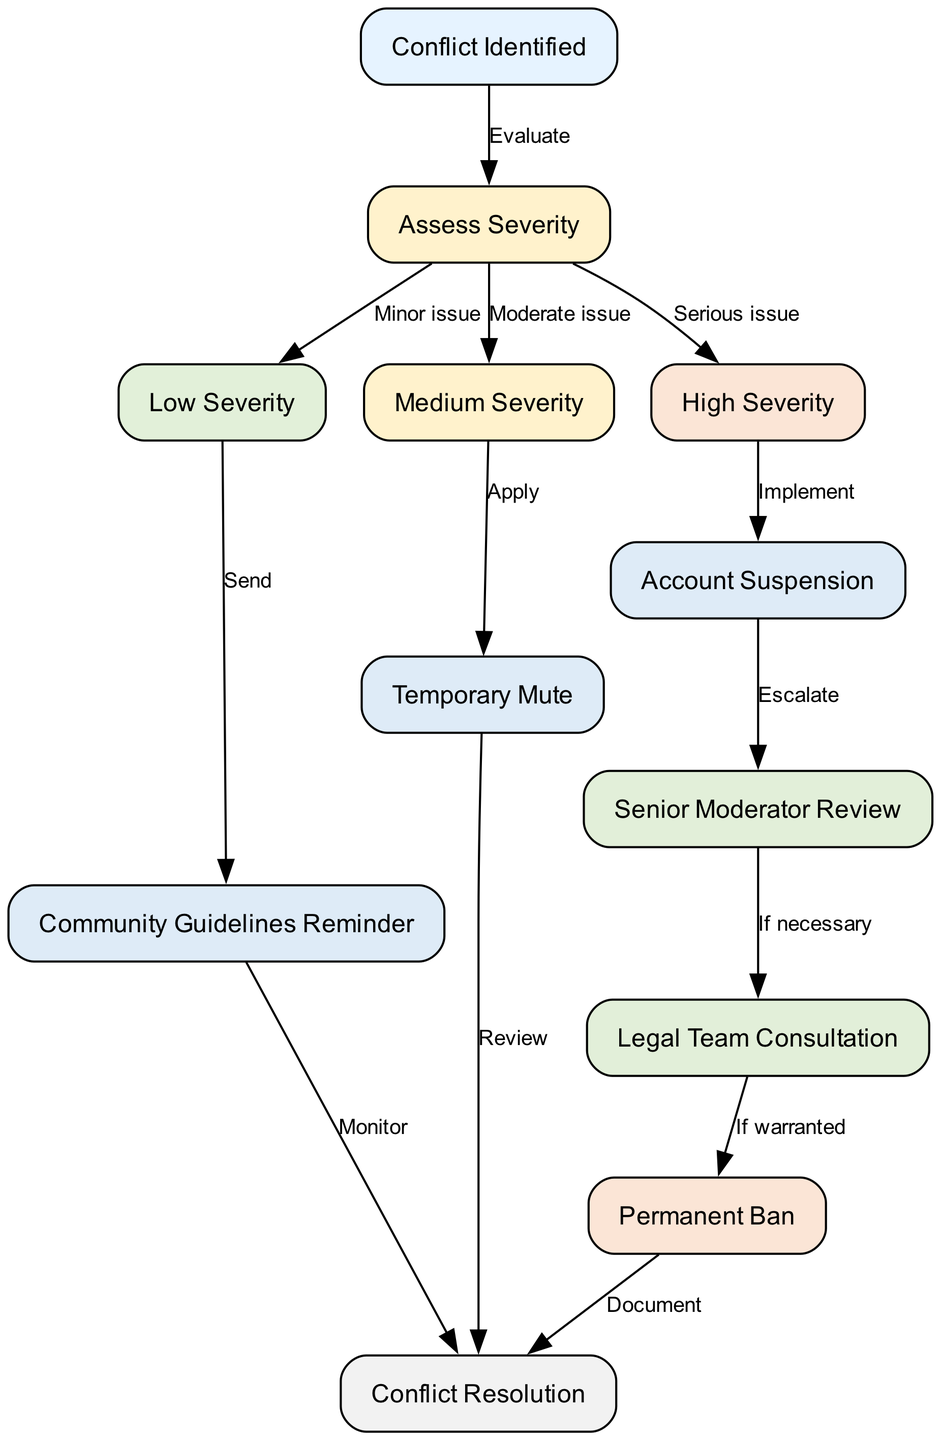What is the first node in the diagram? The first node in the diagram is labeled "Conflict Identified". It is the starting point of the flowchart, indicating where the escalation process begins.
Answer: Conflict Identified How many nodes are present in the diagram? To find the number of nodes, we simply count the unique entries listed under the "nodes" section of the data. There are a total of 12 nodes.
Answer: 12 What action follows a "High Severity" conflict? Following a "High Severity" conflict, the flow indicates that "Account Suspension" is to be implemented as a response to that level of conflict severity.
Answer: Account Suspension What is the outcome of sending a Community Guidelines Reminder? The outcome of sending a Community Guidelines Reminder is that it leads to the "Conflict Resolution" node after monitoring the situation.
Answer: Conflict Resolution What does the "Senior Moderator Review" node lead to, if necessary? If necessary, the "Senior Moderator Review" node leads to the "Legal Team Consultation". This shows the process of escalating the situation to legal if additional intervention is warranted.
Answer: Legal Team Consultation How is the "Medium Severity" conflict addressed? A "Medium Severity" conflict is addressed by applying a "Temporary Mute" as indicated in the flowchart connecting the "Medium Severity" node to the action node.
Answer: Temporary Mute What is the final step after implementing a "Permanent Ban"? After implementing a "Permanent Ban", the diagram indicates that the final step is to "Document" the action taken, ensuring that there's a record of the decision.
Answer: Document What are the possible actions for a "Low Severity" conflict? For a "Low Severity" conflict, the only action indicated is sending a "Community Guidelines Reminder" while monitoring for any further issues that may arise.
Answer: Community Guidelines Reminder What type of issue is classified as being in the "High Severity" category? A "High Severity" category issue is classified as a "Serious issue" which requires immediate attention and follows specific escalation procedures leading to account suspension.
Answer: Serious issue 